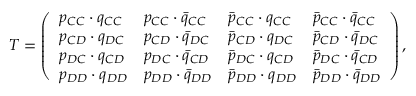Convert formula to latex. <formula><loc_0><loc_0><loc_500><loc_500>T = \left ( \begin{array} { l l l l } { p _ { C C } \cdot q _ { C C } } & { p _ { C C } \cdot \bar { q } _ { C C } } & { \bar { p } _ { C C } \cdot q _ { C C } } & { \bar { p } _ { C C } \cdot \bar { q } _ { C C } } \\ { p _ { C D } \cdot q _ { D C } } & { p _ { C D } \cdot \bar { q } _ { D C } } & { \bar { p } _ { C D } \cdot q _ { D C } } & { \bar { p } _ { C D } \cdot \bar { q } _ { D C } } \\ { p _ { D C } \cdot q _ { C D } } & { p _ { D C } \cdot \bar { q } _ { C D } } & { \bar { p } _ { D C } \cdot q _ { C D } } & { \bar { p } _ { D C } \cdot \bar { q } _ { C D } } \\ { p _ { D D } \cdot q _ { D D } } & { p _ { D D } \cdot \bar { q } _ { D D } } & { \bar { p } _ { D D } \cdot q _ { D D } } & { \bar { p } _ { D D } \cdot \bar { q } _ { D D } } \end{array} \right ) ,</formula> 